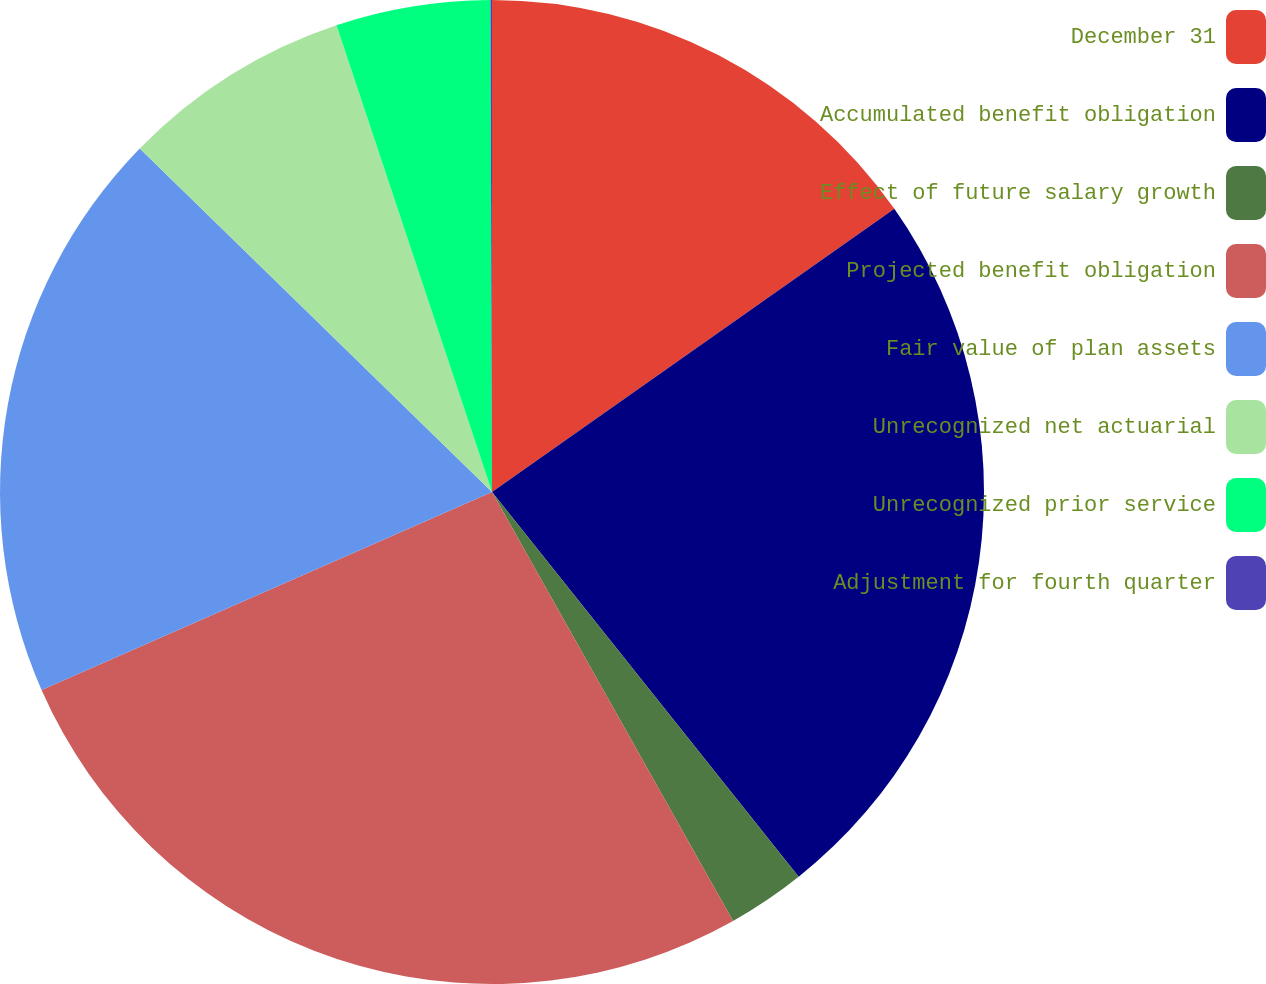Convert chart to OTSL. <chart><loc_0><loc_0><loc_500><loc_500><pie_chart><fcel>December 31<fcel>Accumulated benefit obligation<fcel>Effect of future salary growth<fcel>Projected benefit obligation<fcel>Fair value of plan assets<fcel>Unrecognized net actuarial<fcel>Unrecognized prior service<fcel>Adjustment for fourth quarter<nl><fcel>15.24%<fcel>24.05%<fcel>2.56%<fcel>26.56%<fcel>18.89%<fcel>7.58%<fcel>5.07%<fcel>0.05%<nl></chart> 